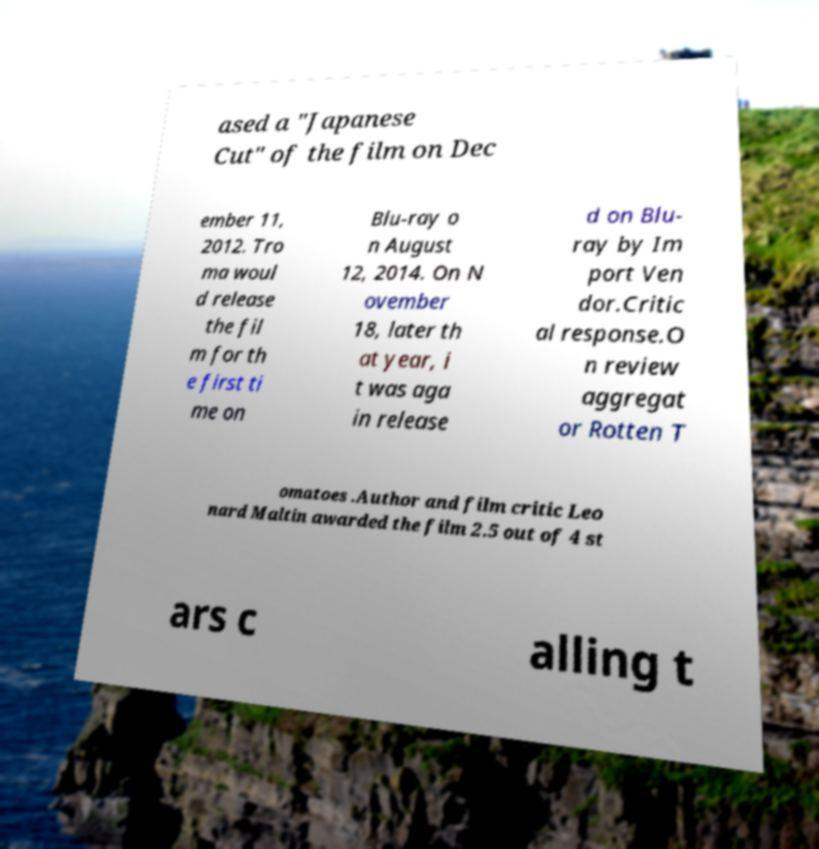What messages or text are displayed in this image? I need them in a readable, typed format. ased a "Japanese Cut" of the film on Dec ember 11, 2012. Tro ma woul d release the fil m for th e first ti me on Blu-ray o n August 12, 2014. On N ovember 18, later th at year, i t was aga in release d on Blu- ray by Im port Ven dor.Critic al response.O n review aggregat or Rotten T omatoes .Author and film critic Leo nard Maltin awarded the film 2.5 out of 4 st ars c alling t 